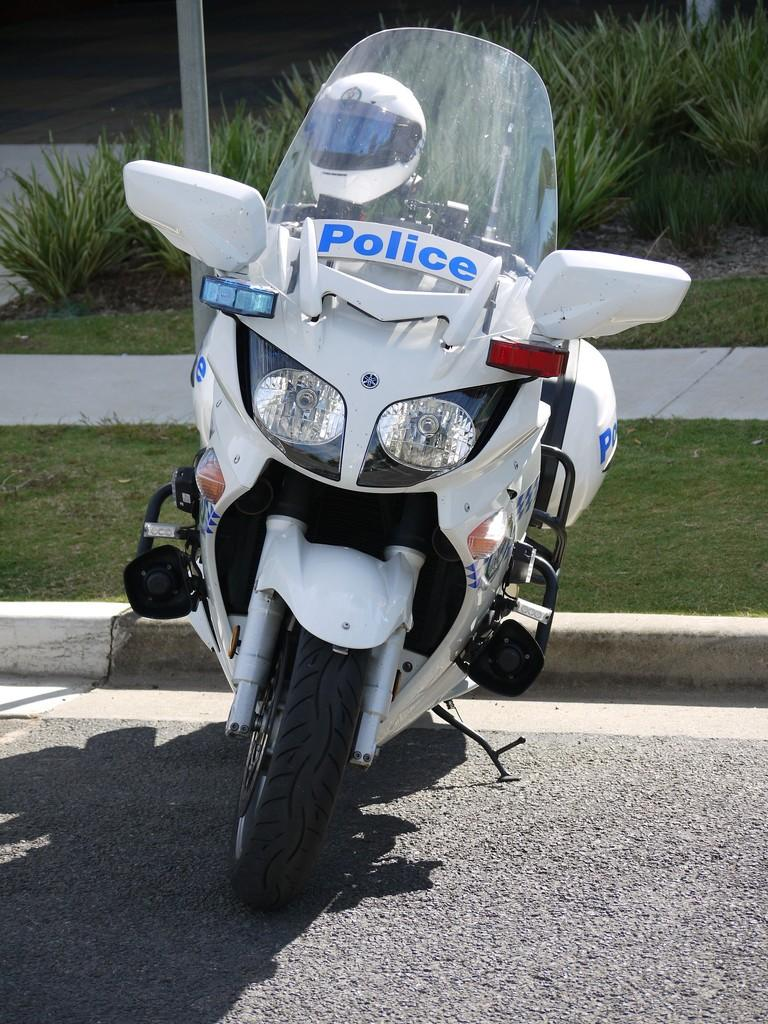What color is the bike in the image? The bike in the image is white. Where is the bike located? The bike is on the road. What can be seen in the background of the image? There is a pole, grass, and green plants visible in the background. What year is the basketball game taking place in the image? There is no basketball game present in the image, so it is not possible to determine the year. 